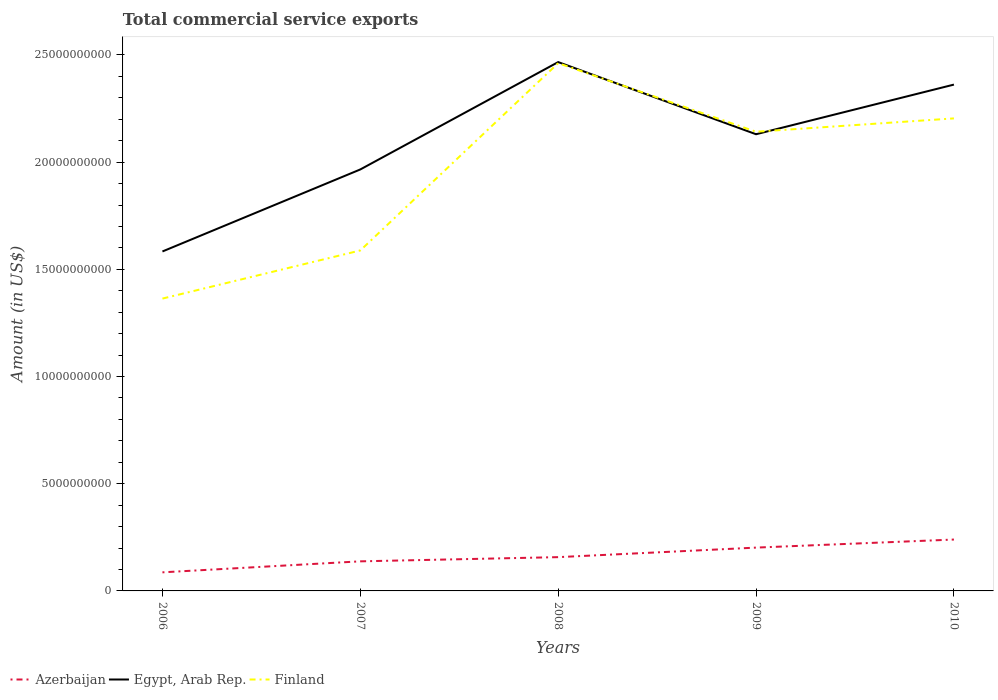Does the line corresponding to Egypt, Arab Rep. intersect with the line corresponding to Finland?
Make the answer very short. Yes. Across all years, what is the maximum total commercial service exports in Egypt, Arab Rep.?
Ensure brevity in your answer.  1.58e+1. What is the total total commercial service exports in Finland in the graph?
Provide a succinct answer. 3.20e+09. What is the difference between the highest and the second highest total commercial service exports in Egypt, Arab Rep.?
Provide a short and direct response. 8.83e+09. What is the difference between the highest and the lowest total commercial service exports in Azerbaijan?
Provide a short and direct response. 2. How many lines are there?
Offer a very short reply. 3. How many years are there in the graph?
Provide a succinct answer. 5. Are the values on the major ticks of Y-axis written in scientific E-notation?
Your answer should be very brief. No. What is the title of the graph?
Your response must be concise. Total commercial service exports. Does "Bahrain" appear as one of the legend labels in the graph?
Make the answer very short. No. What is the label or title of the Y-axis?
Ensure brevity in your answer.  Amount (in US$). What is the Amount (in US$) of Azerbaijan in 2006?
Offer a terse response. 8.67e+08. What is the Amount (in US$) of Egypt, Arab Rep. in 2006?
Offer a very short reply. 1.58e+1. What is the Amount (in US$) in Finland in 2006?
Give a very brief answer. 1.36e+1. What is the Amount (in US$) in Azerbaijan in 2007?
Your response must be concise. 1.38e+09. What is the Amount (in US$) of Egypt, Arab Rep. in 2007?
Offer a very short reply. 1.97e+1. What is the Amount (in US$) in Finland in 2007?
Make the answer very short. 1.59e+1. What is the Amount (in US$) of Azerbaijan in 2008?
Give a very brief answer. 1.58e+09. What is the Amount (in US$) of Egypt, Arab Rep. in 2008?
Keep it short and to the point. 2.47e+1. What is the Amount (in US$) of Finland in 2008?
Ensure brevity in your answer.  2.46e+1. What is the Amount (in US$) of Azerbaijan in 2009?
Your answer should be compact. 2.02e+09. What is the Amount (in US$) of Egypt, Arab Rep. in 2009?
Give a very brief answer. 2.13e+1. What is the Amount (in US$) of Finland in 2009?
Keep it short and to the point. 2.14e+1. What is the Amount (in US$) in Azerbaijan in 2010?
Ensure brevity in your answer.  2.40e+09. What is the Amount (in US$) in Egypt, Arab Rep. in 2010?
Ensure brevity in your answer.  2.36e+1. What is the Amount (in US$) in Finland in 2010?
Your answer should be very brief. 2.20e+1. Across all years, what is the maximum Amount (in US$) of Azerbaijan?
Provide a short and direct response. 2.40e+09. Across all years, what is the maximum Amount (in US$) of Egypt, Arab Rep.?
Keep it short and to the point. 2.47e+1. Across all years, what is the maximum Amount (in US$) in Finland?
Your answer should be very brief. 2.46e+1. Across all years, what is the minimum Amount (in US$) of Azerbaijan?
Your answer should be compact. 8.67e+08. Across all years, what is the minimum Amount (in US$) in Egypt, Arab Rep.?
Offer a terse response. 1.58e+1. Across all years, what is the minimum Amount (in US$) in Finland?
Your answer should be very brief. 1.36e+1. What is the total Amount (in US$) of Azerbaijan in the graph?
Offer a terse response. 8.24e+09. What is the total Amount (in US$) of Egypt, Arab Rep. in the graph?
Ensure brevity in your answer.  1.05e+11. What is the total Amount (in US$) in Finland in the graph?
Offer a very short reply. 9.76e+1. What is the difference between the Amount (in US$) of Azerbaijan in 2006 and that in 2007?
Your response must be concise. -5.13e+08. What is the difference between the Amount (in US$) in Egypt, Arab Rep. in 2006 and that in 2007?
Make the answer very short. -3.83e+09. What is the difference between the Amount (in US$) of Finland in 2006 and that in 2007?
Provide a short and direct response. -2.25e+09. What is the difference between the Amount (in US$) in Azerbaijan in 2006 and that in 2008?
Ensure brevity in your answer.  -7.09e+08. What is the difference between the Amount (in US$) in Egypt, Arab Rep. in 2006 and that in 2008?
Provide a short and direct response. -8.83e+09. What is the difference between the Amount (in US$) in Finland in 2006 and that in 2008?
Keep it short and to the point. -1.10e+1. What is the difference between the Amount (in US$) in Azerbaijan in 2006 and that in 2009?
Provide a succinct answer. -1.15e+09. What is the difference between the Amount (in US$) in Egypt, Arab Rep. in 2006 and that in 2009?
Your answer should be very brief. -5.47e+09. What is the difference between the Amount (in US$) of Finland in 2006 and that in 2009?
Provide a short and direct response. -7.78e+09. What is the difference between the Amount (in US$) of Azerbaijan in 2006 and that in 2010?
Your answer should be compact. -1.53e+09. What is the difference between the Amount (in US$) of Egypt, Arab Rep. in 2006 and that in 2010?
Your answer should be compact. -7.78e+09. What is the difference between the Amount (in US$) of Finland in 2006 and that in 2010?
Offer a terse response. -8.40e+09. What is the difference between the Amount (in US$) in Azerbaijan in 2007 and that in 2008?
Offer a terse response. -1.96e+08. What is the difference between the Amount (in US$) in Egypt, Arab Rep. in 2007 and that in 2008?
Offer a very short reply. -5.01e+09. What is the difference between the Amount (in US$) of Finland in 2007 and that in 2008?
Your answer should be compact. -8.74e+09. What is the difference between the Amount (in US$) of Azerbaijan in 2007 and that in 2009?
Make the answer very short. -6.41e+08. What is the difference between the Amount (in US$) in Egypt, Arab Rep. in 2007 and that in 2009?
Offer a very short reply. -1.64e+09. What is the difference between the Amount (in US$) in Finland in 2007 and that in 2009?
Your response must be concise. -5.54e+09. What is the difference between the Amount (in US$) of Azerbaijan in 2007 and that in 2010?
Provide a short and direct response. -1.02e+09. What is the difference between the Amount (in US$) in Egypt, Arab Rep. in 2007 and that in 2010?
Offer a very short reply. -3.96e+09. What is the difference between the Amount (in US$) in Finland in 2007 and that in 2010?
Make the answer very short. -6.16e+09. What is the difference between the Amount (in US$) of Azerbaijan in 2008 and that in 2009?
Your response must be concise. -4.45e+08. What is the difference between the Amount (in US$) in Egypt, Arab Rep. in 2008 and that in 2009?
Keep it short and to the point. 3.37e+09. What is the difference between the Amount (in US$) of Finland in 2008 and that in 2009?
Give a very brief answer. 3.20e+09. What is the difference between the Amount (in US$) in Azerbaijan in 2008 and that in 2010?
Ensure brevity in your answer.  -8.21e+08. What is the difference between the Amount (in US$) of Egypt, Arab Rep. in 2008 and that in 2010?
Offer a very short reply. 1.05e+09. What is the difference between the Amount (in US$) in Finland in 2008 and that in 2010?
Ensure brevity in your answer.  2.58e+09. What is the difference between the Amount (in US$) of Azerbaijan in 2009 and that in 2010?
Your response must be concise. -3.76e+08. What is the difference between the Amount (in US$) of Egypt, Arab Rep. in 2009 and that in 2010?
Offer a terse response. -2.32e+09. What is the difference between the Amount (in US$) of Finland in 2009 and that in 2010?
Provide a short and direct response. -6.22e+08. What is the difference between the Amount (in US$) in Azerbaijan in 2006 and the Amount (in US$) in Egypt, Arab Rep. in 2007?
Make the answer very short. -1.88e+1. What is the difference between the Amount (in US$) of Azerbaijan in 2006 and the Amount (in US$) of Finland in 2007?
Offer a very short reply. -1.50e+1. What is the difference between the Amount (in US$) of Egypt, Arab Rep. in 2006 and the Amount (in US$) of Finland in 2007?
Ensure brevity in your answer.  -4.77e+07. What is the difference between the Amount (in US$) of Azerbaijan in 2006 and the Amount (in US$) of Egypt, Arab Rep. in 2008?
Your answer should be compact. -2.38e+1. What is the difference between the Amount (in US$) of Azerbaijan in 2006 and the Amount (in US$) of Finland in 2008?
Offer a very short reply. -2.38e+1. What is the difference between the Amount (in US$) in Egypt, Arab Rep. in 2006 and the Amount (in US$) in Finland in 2008?
Offer a very short reply. -8.78e+09. What is the difference between the Amount (in US$) of Azerbaijan in 2006 and the Amount (in US$) of Egypt, Arab Rep. in 2009?
Provide a succinct answer. -2.04e+1. What is the difference between the Amount (in US$) of Azerbaijan in 2006 and the Amount (in US$) of Finland in 2009?
Offer a terse response. -2.06e+1. What is the difference between the Amount (in US$) of Egypt, Arab Rep. in 2006 and the Amount (in US$) of Finland in 2009?
Offer a very short reply. -5.59e+09. What is the difference between the Amount (in US$) of Azerbaijan in 2006 and the Amount (in US$) of Egypt, Arab Rep. in 2010?
Offer a very short reply. -2.28e+1. What is the difference between the Amount (in US$) of Azerbaijan in 2006 and the Amount (in US$) of Finland in 2010?
Provide a short and direct response. -2.12e+1. What is the difference between the Amount (in US$) of Egypt, Arab Rep. in 2006 and the Amount (in US$) of Finland in 2010?
Your answer should be very brief. -6.21e+09. What is the difference between the Amount (in US$) in Azerbaijan in 2007 and the Amount (in US$) in Egypt, Arab Rep. in 2008?
Keep it short and to the point. -2.33e+1. What is the difference between the Amount (in US$) in Azerbaijan in 2007 and the Amount (in US$) in Finland in 2008?
Keep it short and to the point. -2.32e+1. What is the difference between the Amount (in US$) in Egypt, Arab Rep. in 2007 and the Amount (in US$) in Finland in 2008?
Ensure brevity in your answer.  -4.96e+09. What is the difference between the Amount (in US$) in Azerbaijan in 2007 and the Amount (in US$) in Egypt, Arab Rep. in 2009?
Provide a short and direct response. -1.99e+1. What is the difference between the Amount (in US$) of Azerbaijan in 2007 and the Amount (in US$) of Finland in 2009?
Provide a succinct answer. -2.00e+1. What is the difference between the Amount (in US$) of Egypt, Arab Rep. in 2007 and the Amount (in US$) of Finland in 2009?
Your answer should be compact. -1.76e+09. What is the difference between the Amount (in US$) in Azerbaijan in 2007 and the Amount (in US$) in Egypt, Arab Rep. in 2010?
Your answer should be compact. -2.22e+1. What is the difference between the Amount (in US$) in Azerbaijan in 2007 and the Amount (in US$) in Finland in 2010?
Give a very brief answer. -2.07e+1. What is the difference between the Amount (in US$) in Egypt, Arab Rep. in 2007 and the Amount (in US$) in Finland in 2010?
Your response must be concise. -2.38e+09. What is the difference between the Amount (in US$) in Azerbaijan in 2008 and the Amount (in US$) in Egypt, Arab Rep. in 2009?
Make the answer very short. -1.97e+1. What is the difference between the Amount (in US$) in Azerbaijan in 2008 and the Amount (in US$) in Finland in 2009?
Keep it short and to the point. -1.98e+1. What is the difference between the Amount (in US$) in Egypt, Arab Rep. in 2008 and the Amount (in US$) in Finland in 2009?
Your response must be concise. 3.25e+09. What is the difference between the Amount (in US$) of Azerbaijan in 2008 and the Amount (in US$) of Egypt, Arab Rep. in 2010?
Provide a short and direct response. -2.20e+1. What is the difference between the Amount (in US$) in Azerbaijan in 2008 and the Amount (in US$) in Finland in 2010?
Offer a terse response. -2.05e+1. What is the difference between the Amount (in US$) in Egypt, Arab Rep. in 2008 and the Amount (in US$) in Finland in 2010?
Provide a short and direct response. 2.63e+09. What is the difference between the Amount (in US$) of Azerbaijan in 2009 and the Amount (in US$) of Egypt, Arab Rep. in 2010?
Your answer should be compact. -2.16e+1. What is the difference between the Amount (in US$) of Azerbaijan in 2009 and the Amount (in US$) of Finland in 2010?
Your answer should be compact. -2.00e+1. What is the difference between the Amount (in US$) of Egypt, Arab Rep. in 2009 and the Amount (in US$) of Finland in 2010?
Your answer should be compact. -7.39e+08. What is the average Amount (in US$) in Azerbaijan per year?
Provide a succinct answer. 1.65e+09. What is the average Amount (in US$) of Egypt, Arab Rep. per year?
Ensure brevity in your answer.  2.10e+1. What is the average Amount (in US$) in Finland per year?
Your answer should be very brief. 1.95e+1. In the year 2006, what is the difference between the Amount (in US$) of Azerbaijan and Amount (in US$) of Egypt, Arab Rep.?
Your answer should be very brief. -1.50e+1. In the year 2006, what is the difference between the Amount (in US$) of Azerbaijan and Amount (in US$) of Finland?
Provide a short and direct response. -1.28e+1. In the year 2006, what is the difference between the Amount (in US$) in Egypt, Arab Rep. and Amount (in US$) in Finland?
Your answer should be compact. 2.20e+09. In the year 2007, what is the difference between the Amount (in US$) in Azerbaijan and Amount (in US$) in Egypt, Arab Rep.?
Provide a succinct answer. -1.83e+1. In the year 2007, what is the difference between the Amount (in US$) in Azerbaijan and Amount (in US$) in Finland?
Your answer should be compact. -1.45e+1. In the year 2007, what is the difference between the Amount (in US$) of Egypt, Arab Rep. and Amount (in US$) of Finland?
Give a very brief answer. 3.78e+09. In the year 2008, what is the difference between the Amount (in US$) of Azerbaijan and Amount (in US$) of Egypt, Arab Rep.?
Provide a short and direct response. -2.31e+1. In the year 2008, what is the difference between the Amount (in US$) of Azerbaijan and Amount (in US$) of Finland?
Ensure brevity in your answer.  -2.30e+1. In the year 2008, what is the difference between the Amount (in US$) of Egypt, Arab Rep. and Amount (in US$) of Finland?
Provide a succinct answer. 4.95e+07. In the year 2009, what is the difference between the Amount (in US$) in Azerbaijan and Amount (in US$) in Egypt, Arab Rep.?
Your answer should be very brief. -1.93e+1. In the year 2009, what is the difference between the Amount (in US$) of Azerbaijan and Amount (in US$) of Finland?
Give a very brief answer. -1.94e+1. In the year 2009, what is the difference between the Amount (in US$) in Egypt, Arab Rep. and Amount (in US$) in Finland?
Your response must be concise. -1.17e+08. In the year 2010, what is the difference between the Amount (in US$) of Azerbaijan and Amount (in US$) of Egypt, Arab Rep.?
Keep it short and to the point. -2.12e+1. In the year 2010, what is the difference between the Amount (in US$) in Azerbaijan and Amount (in US$) in Finland?
Offer a terse response. -1.96e+1. In the year 2010, what is the difference between the Amount (in US$) of Egypt, Arab Rep. and Amount (in US$) of Finland?
Ensure brevity in your answer.  1.58e+09. What is the ratio of the Amount (in US$) in Azerbaijan in 2006 to that in 2007?
Give a very brief answer. 0.63. What is the ratio of the Amount (in US$) in Egypt, Arab Rep. in 2006 to that in 2007?
Give a very brief answer. 0.81. What is the ratio of the Amount (in US$) of Finland in 2006 to that in 2007?
Offer a very short reply. 0.86. What is the ratio of the Amount (in US$) of Azerbaijan in 2006 to that in 2008?
Give a very brief answer. 0.55. What is the ratio of the Amount (in US$) of Egypt, Arab Rep. in 2006 to that in 2008?
Offer a very short reply. 0.64. What is the ratio of the Amount (in US$) in Finland in 2006 to that in 2008?
Make the answer very short. 0.55. What is the ratio of the Amount (in US$) in Azerbaijan in 2006 to that in 2009?
Provide a succinct answer. 0.43. What is the ratio of the Amount (in US$) of Egypt, Arab Rep. in 2006 to that in 2009?
Your response must be concise. 0.74. What is the ratio of the Amount (in US$) of Finland in 2006 to that in 2009?
Provide a short and direct response. 0.64. What is the ratio of the Amount (in US$) in Azerbaijan in 2006 to that in 2010?
Provide a short and direct response. 0.36. What is the ratio of the Amount (in US$) of Egypt, Arab Rep. in 2006 to that in 2010?
Your answer should be compact. 0.67. What is the ratio of the Amount (in US$) of Finland in 2006 to that in 2010?
Your response must be concise. 0.62. What is the ratio of the Amount (in US$) of Azerbaijan in 2007 to that in 2008?
Offer a very short reply. 0.88. What is the ratio of the Amount (in US$) of Egypt, Arab Rep. in 2007 to that in 2008?
Offer a very short reply. 0.8. What is the ratio of the Amount (in US$) of Finland in 2007 to that in 2008?
Keep it short and to the point. 0.65. What is the ratio of the Amount (in US$) in Azerbaijan in 2007 to that in 2009?
Keep it short and to the point. 0.68. What is the ratio of the Amount (in US$) in Egypt, Arab Rep. in 2007 to that in 2009?
Offer a very short reply. 0.92. What is the ratio of the Amount (in US$) of Finland in 2007 to that in 2009?
Provide a short and direct response. 0.74. What is the ratio of the Amount (in US$) of Azerbaijan in 2007 to that in 2010?
Your response must be concise. 0.58. What is the ratio of the Amount (in US$) of Egypt, Arab Rep. in 2007 to that in 2010?
Your response must be concise. 0.83. What is the ratio of the Amount (in US$) in Finland in 2007 to that in 2010?
Your response must be concise. 0.72. What is the ratio of the Amount (in US$) of Azerbaijan in 2008 to that in 2009?
Make the answer very short. 0.78. What is the ratio of the Amount (in US$) in Egypt, Arab Rep. in 2008 to that in 2009?
Ensure brevity in your answer.  1.16. What is the ratio of the Amount (in US$) of Finland in 2008 to that in 2009?
Your answer should be compact. 1.15. What is the ratio of the Amount (in US$) in Azerbaijan in 2008 to that in 2010?
Offer a very short reply. 0.66. What is the ratio of the Amount (in US$) in Egypt, Arab Rep. in 2008 to that in 2010?
Give a very brief answer. 1.04. What is the ratio of the Amount (in US$) in Finland in 2008 to that in 2010?
Make the answer very short. 1.12. What is the ratio of the Amount (in US$) of Azerbaijan in 2009 to that in 2010?
Provide a succinct answer. 0.84. What is the ratio of the Amount (in US$) in Egypt, Arab Rep. in 2009 to that in 2010?
Give a very brief answer. 0.9. What is the ratio of the Amount (in US$) in Finland in 2009 to that in 2010?
Make the answer very short. 0.97. What is the difference between the highest and the second highest Amount (in US$) in Azerbaijan?
Provide a succinct answer. 3.76e+08. What is the difference between the highest and the second highest Amount (in US$) in Egypt, Arab Rep.?
Ensure brevity in your answer.  1.05e+09. What is the difference between the highest and the second highest Amount (in US$) of Finland?
Your answer should be compact. 2.58e+09. What is the difference between the highest and the lowest Amount (in US$) of Azerbaijan?
Offer a very short reply. 1.53e+09. What is the difference between the highest and the lowest Amount (in US$) of Egypt, Arab Rep.?
Your answer should be very brief. 8.83e+09. What is the difference between the highest and the lowest Amount (in US$) in Finland?
Offer a very short reply. 1.10e+1. 